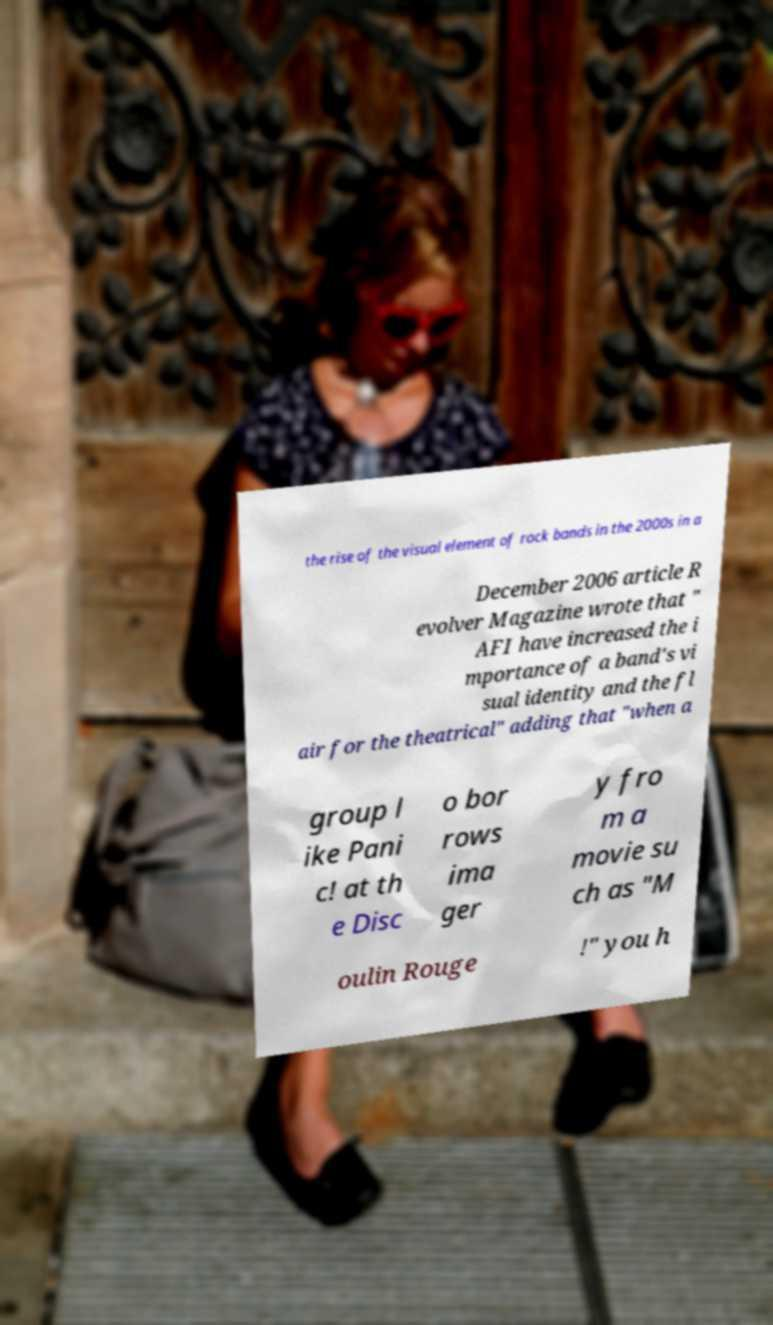I need the written content from this picture converted into text. Can you do that? the rise of the visual element of rock bands in the 2000s in a December 2006 article R evolver Magazine wrote that " AFI have increased the i mportance of a band's vi sual identity and the fl air for the theatrical" adding that "when a group l ike Pani c! at th e Disc o bor rows ima ger y fro m a movie su ch as "M oulin Rouge !" you h 